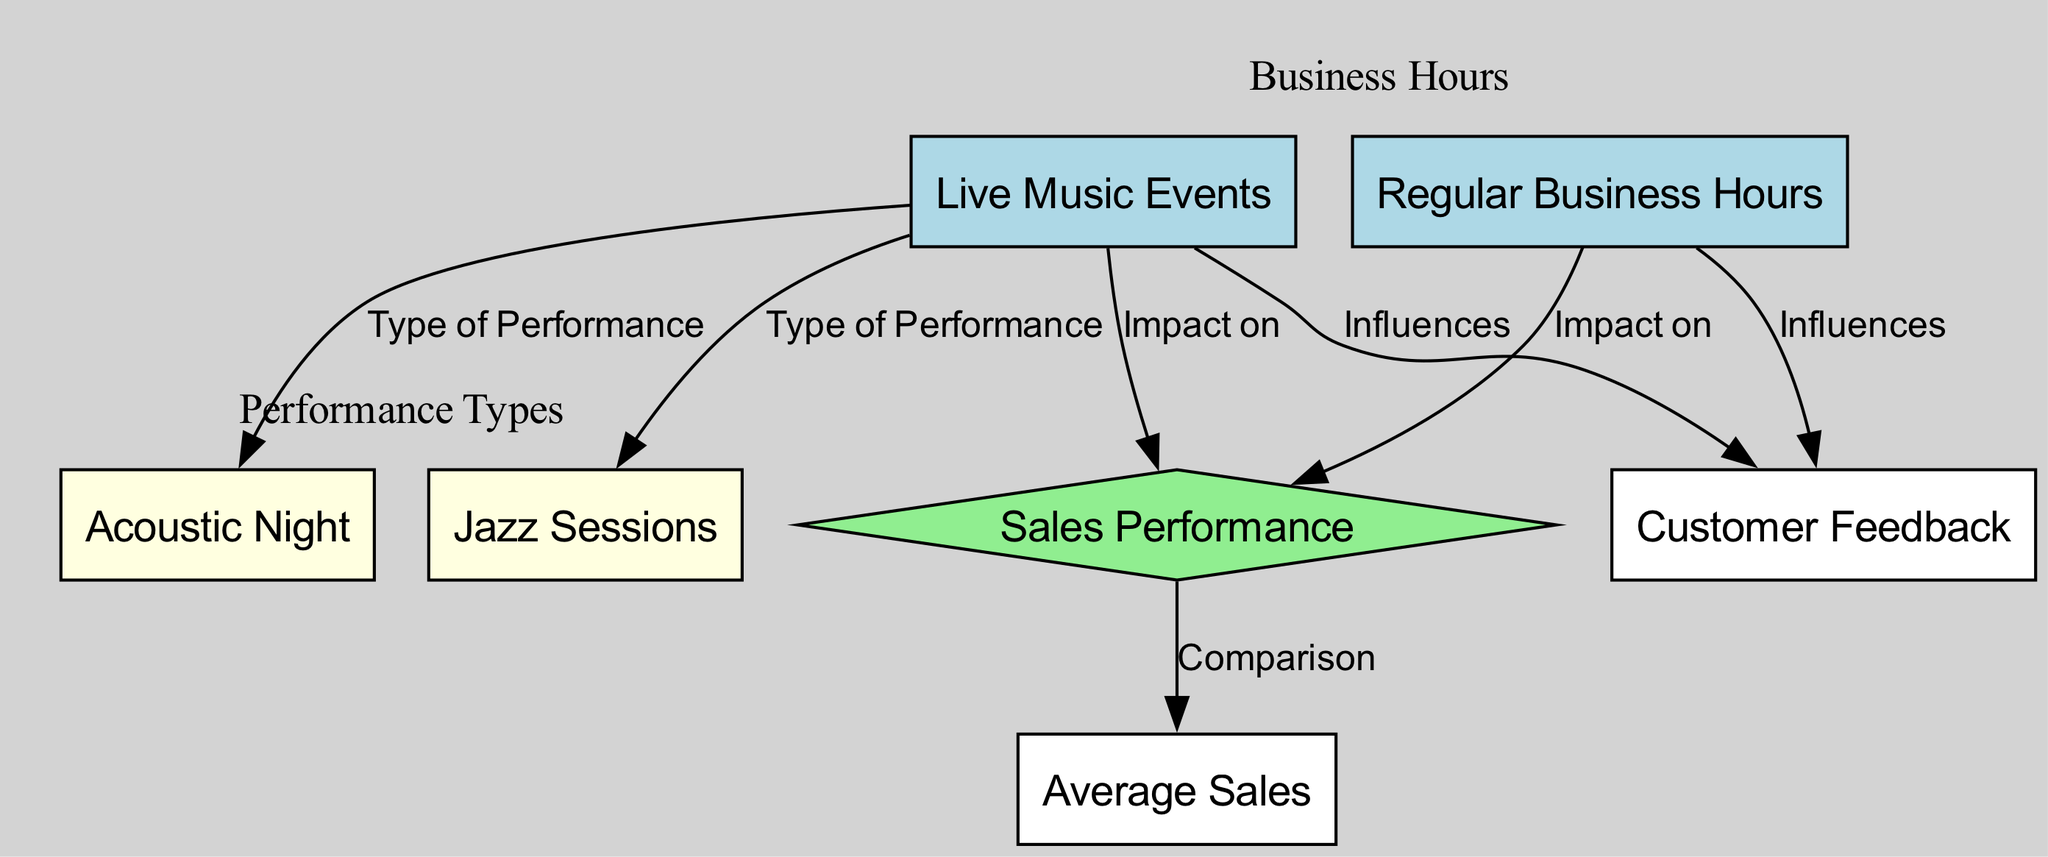What are the two types of performances listed in the diagram? The diagram includes two types of performances under the "Live Music Events" node: "Acoustic Night" and "Jazz Sessions". These nodes are connected to "Live Music Events" indicating they are categories of the performances.
Answer: Acoustic Night and Jazz Sessions How many nodes are present in the diagram? By counting each unique node listed in the diagram, we find a total of 6 nodes: "Live Music Events", "Regular Business Hours", "Acoustic Night", "Jazz Sessions", "Sales Performance", "Customer Feedback".
Answer: 6 Which node influences sales performance during live music events? The "Live Music Events" node has a direct connection to the "Sales Performance" node, indicating it influences the sales performance when live music is played.
Answer: Live Music Events What does the "Sales Performance" node compare? The "Sales Performance" node connects to the "Average Sales" node, indicating that it represents a comparison of sales performance which is generally evaluated.
Answer: Comparison How does customer feedback relate to live music and regular hours? The diagram shows that both "Live Music Events" and "Regular Business Hours" influence "Customer Feedback," which means customer opinions are affected by both types of events.
Answer: Influences Which type of performance is connected to customer feedback? The type of performance that connects to "Customer Feedback" is both "Acoustic Night" and "Jazz Sessions", indicating customer feedback is influenced by these live music events.
Answer: Acoustic Night and Jazz Sessions What impact does "Regular Business Hours" have? The diagram indicates that "Regular Business Hours" has an impact on "Sales Performance", showing the operations during standard hours are accounted for in evaluating sales.
Answer: Impact on Sales Performance What can be inferred about the relationship between live music events and average sales? The diagram shows that "Live Music Events" impacts "Sales Performance," which in turn compares to "Average Sales," indicating that live music can influence the average sales figures positively or negatively.
Answer: Influences Average Sales How many edges are depicted in the diagram? By counting the edges that connect the nodes, we find there are a total of 7 edges present in the diagram, indicating relationships between the nodes.
Answer: 7 